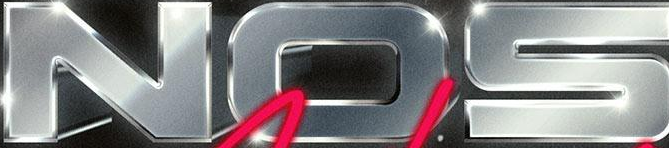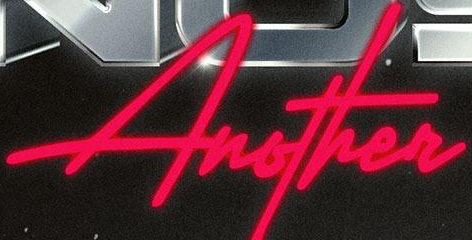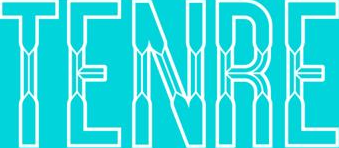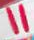What words are shown in these images in order, separated by a semicolon? NOS; Another; TENRE; " 